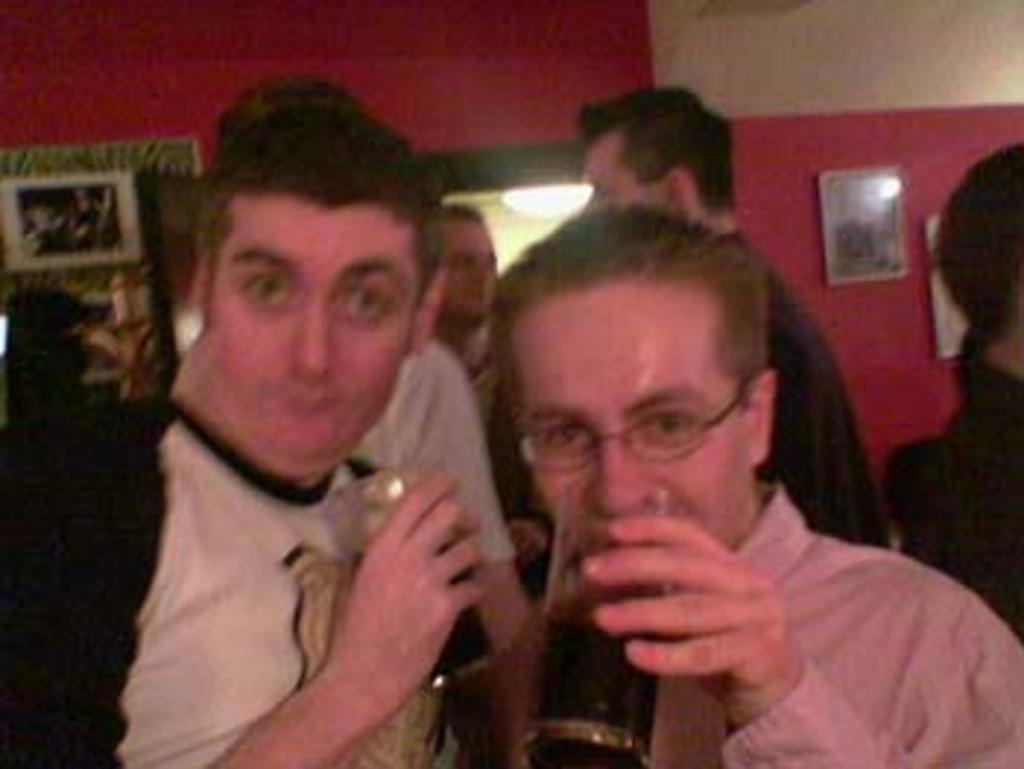What are the people in the image doing? There is a group of people standing on a path in the image. Can you describe any specific actions or objects held by the people? Two people are holding glasses in the image. What can be seen in the background of the image? There is a wall with photo frames in the background of the image. How many parents are present in the image? There is no mention of parents in the image, so it cannot be determined how many are present. 